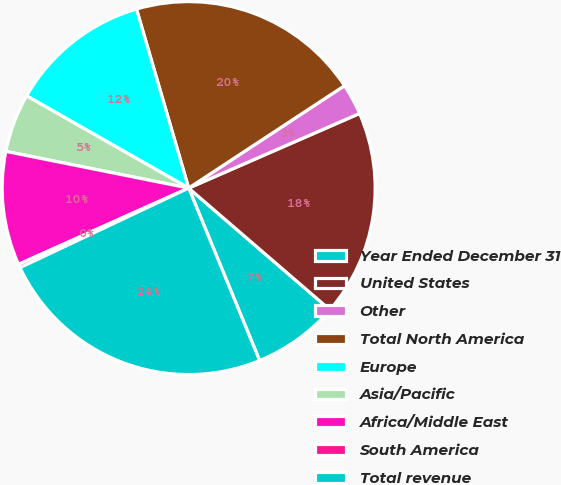Convert chart to OTSL. <chart><loc_0><loc_0><loc_500><loc_500><pie_chart><fcel>Year Ended December 31<fcel>United States<fcel>Other<fcel>Total North America<fcel>Europe<fcel>Asia/Pacific<fcel>Africa/Middle East<fcel>South America<fcel>Total revenue<nl><fcel>7.47%<fcel>17.87%<fcel>2.7%<fcel>20.26%<fcel>12.25%<fcel>5.08%<fcel>9.86%<fcel>0.31%<fcel>24.19%<nl></chart> 